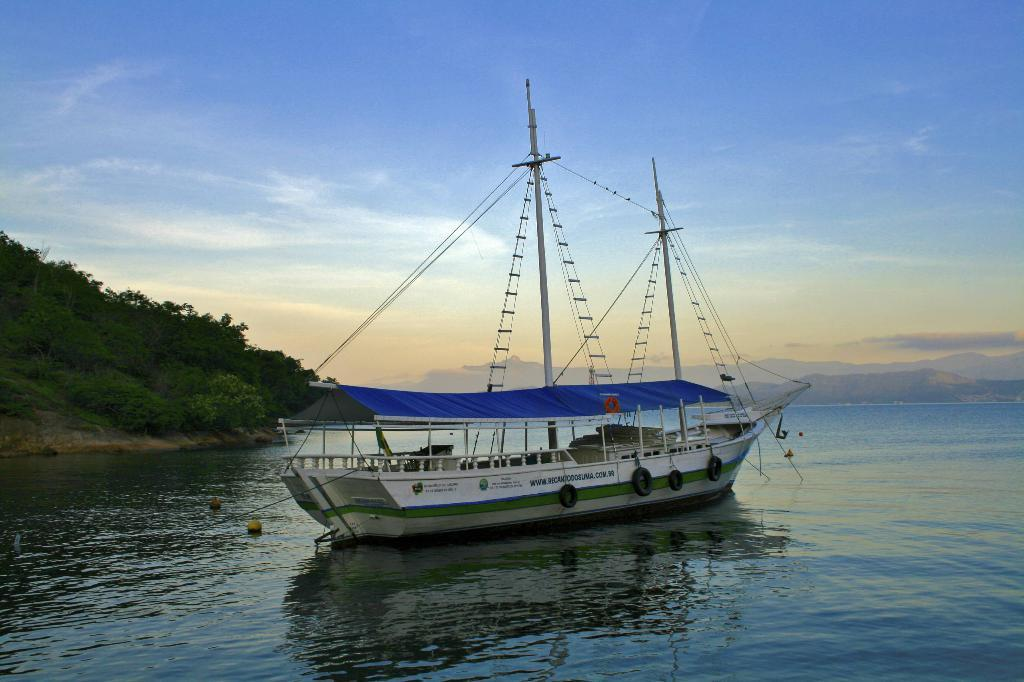What is the primary element in the image? There is water in the image. What is floating on the water? There are objects on the water. What type of vehicle is present in the image? There is a boat with poles in the image. What else can be seen in the image besides the water and boat? There are wires, the ground, plants, mountains, and the sky visible in the image. What is the condition of the sky in the image? The sky is visible in the image, and there are clouds present. What type of bait is being used by the bat in the image? There is no bat or bait present in the image. Is there any snow visible in the image? There is no snow visible in the image; it appears to be a clear day with clouds in the sky. 